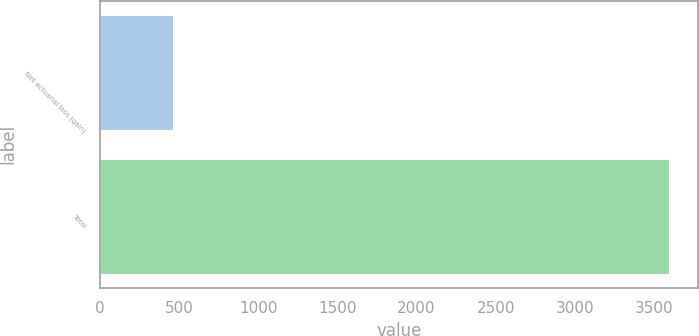<chart> <loc_0><loc_0><loc_500><loc_500><bar_chart><fcel>Net actuarial loss (gain)<fcel>Total<nl><fcel>464<fcel>3596<nl></chart> 